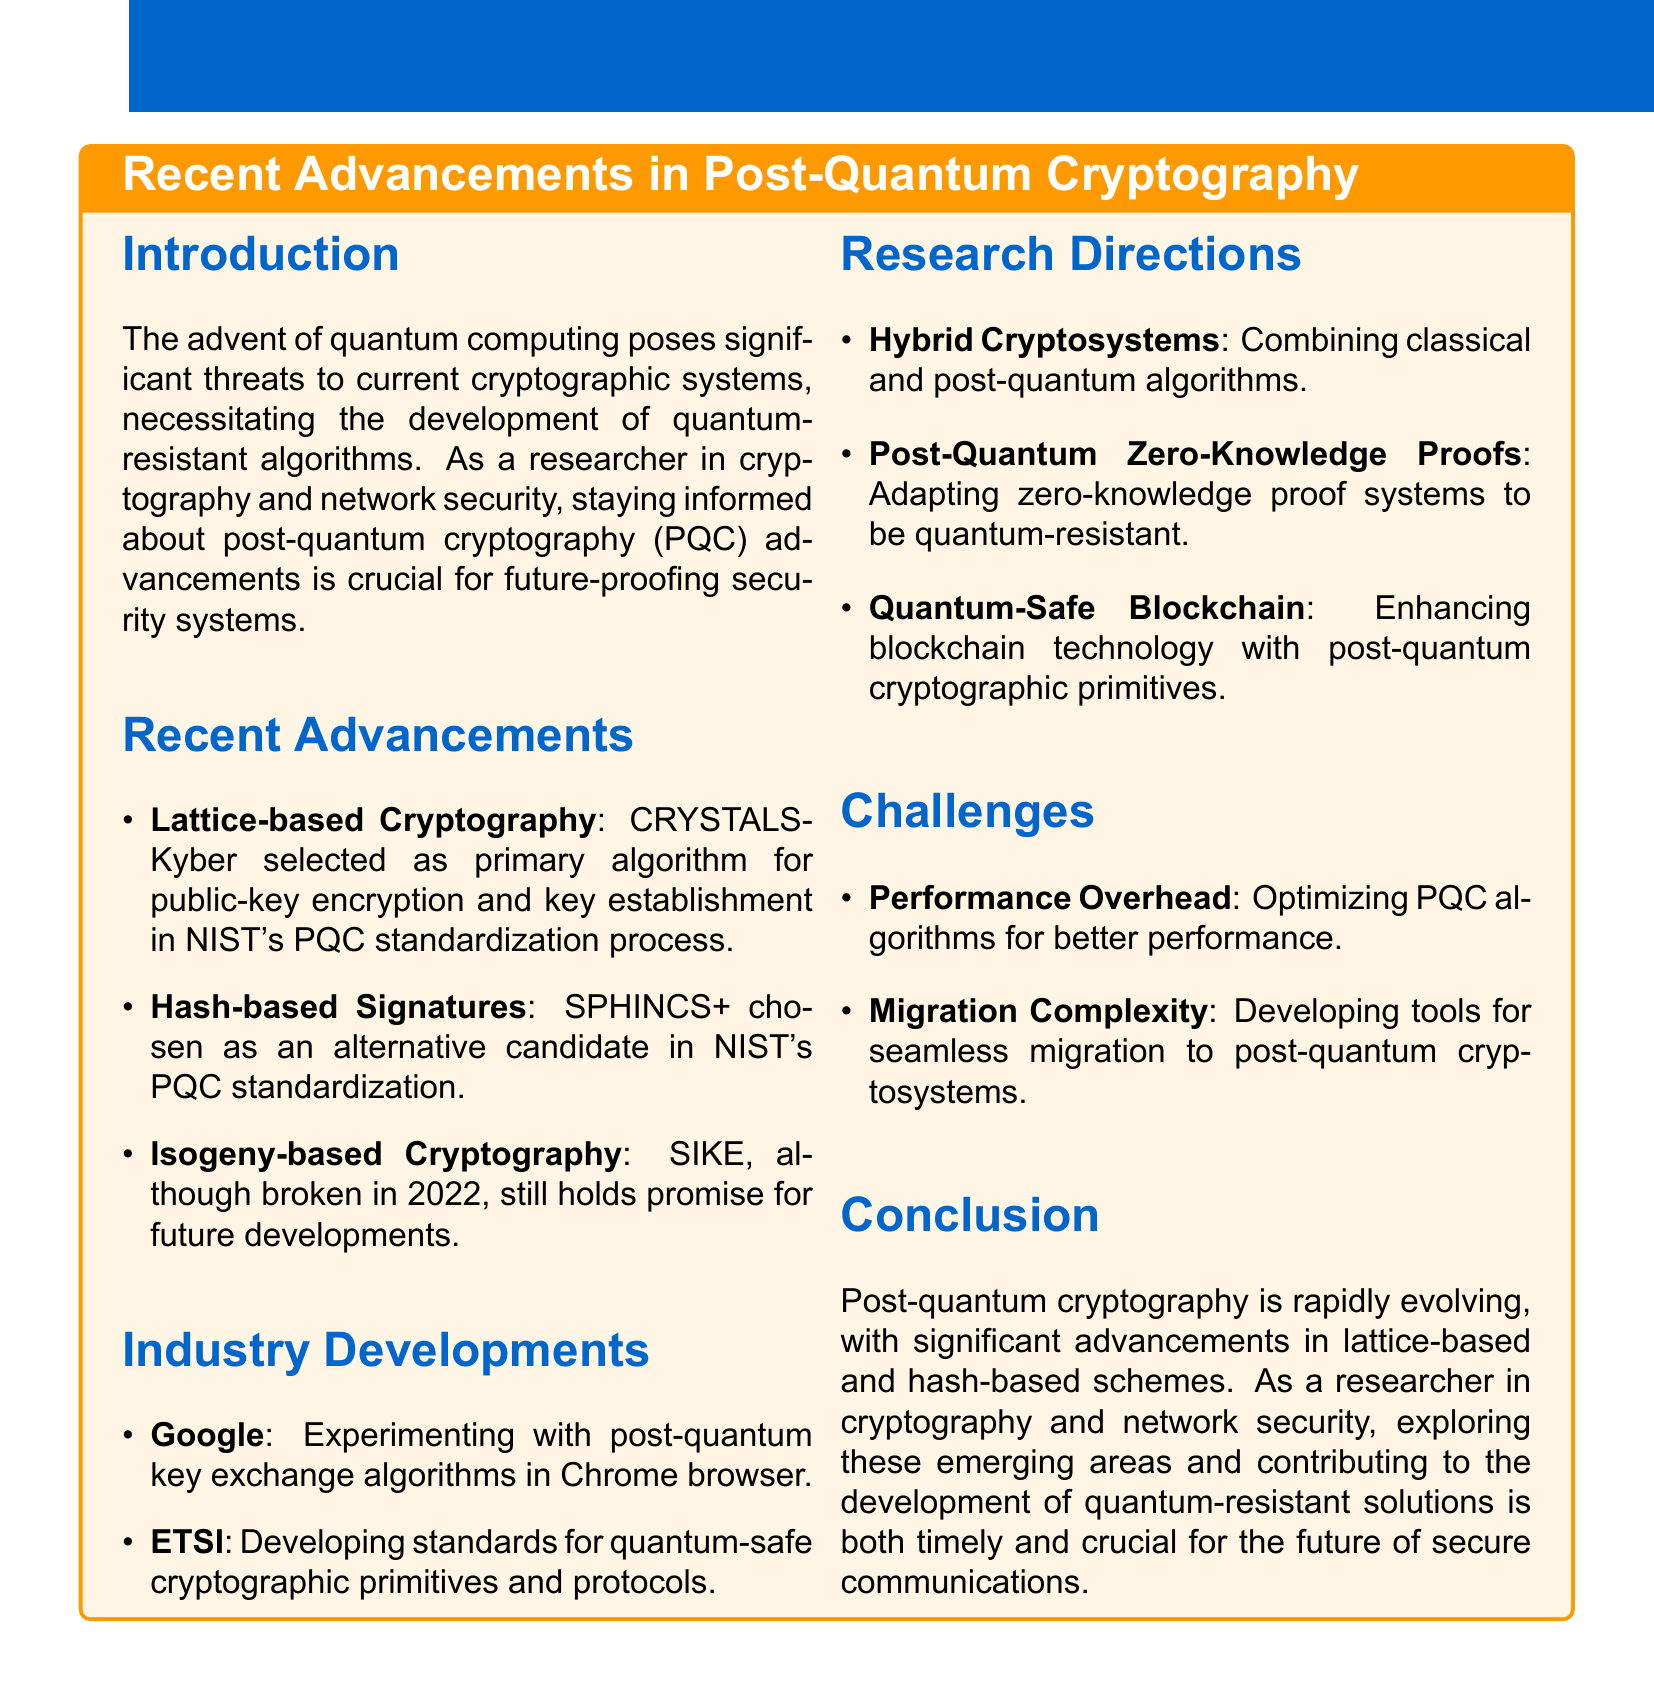What algorithm was selected for public-key encryption? The document states that CRYSTALS-Kyber was selected as the primary algorithm for public-key encryption in NIST's post-quantum cryptography standardization process.
Answer: CRYSTALS-Kyber Which hash-based signature scheme was chosen as an alternative candidate? SPHINCS+ is mentioned as the hash-based signature scheme that was chosen as an alternative candidate in NIST's PQC standardization.
Answer: SPHINCS+ What is a potential research direction for Hybrid Cryptosystems? The potential focus for Hybrid Cryptosystems is developing efficient hybrid schemes for specific use cases like secure communication protocols.
Answer: Developing efficient hybrid schemes Which organization is developing standards for quantum-safe cryptographic primitives? The document mentions ETSI as the organization developing standards for quantum-safe cryptographic primitives and protocols.
Answer: ETSI What is a significant challenge mentioned regarding post-quantum cryptography? The document cites Performance Overhead as a significant challenge related to optimizing PQC algorithms for better performance.
Answer: Performance Overhead What year was SIKE broken? The document specifies that SIKE was broken in 2022, highlighting the vulnerabilities discovered.
Answer: 2022 What is one potential research focus for post-quantum zero-knowledge proofs? The document indicates that a potential focus for post-quantum zero-knowledge proofs is creating efficient protocols for privacy-preserving applications.
Answer: Creating efficient protocols What is the main conclusion regarding post-quantum cryptography advancements? The conclusion states that post-quantum cryptography is rapidly evolving with significant advancements, especially in lattice-based and hash-based schemes.
Answer: Rapidly evolving 